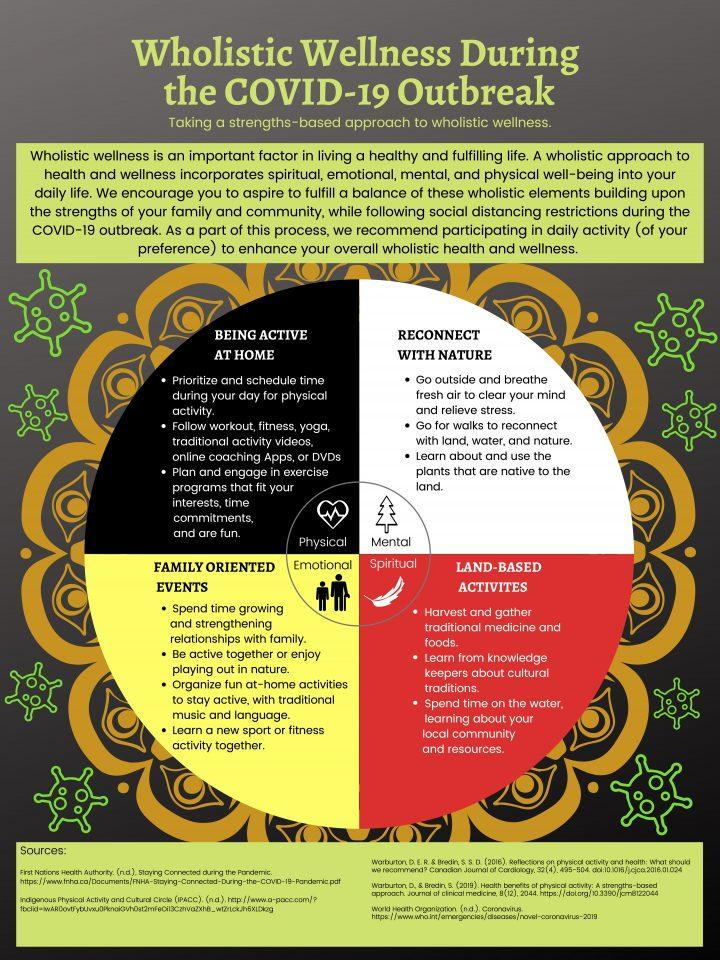Indicate a few pertinent items in this graphic. There are three points listed under the heading "Land Based Activities. According to a wholistic approach, one should choose an exercise that aligns with their interests, fits their time commitments, and is enjoyable in order to achieve optimal results. According to a wholistic view, one should go outside and breathe fresh air in order to forget everything and come out of stress. The fourth point listed under "Family-oriented Events" is to learn a new sport or fitness activity together. According to the holistic view, one should engage in activities such as going for walks in nature to reconnect with nature and promote overall well-being. 